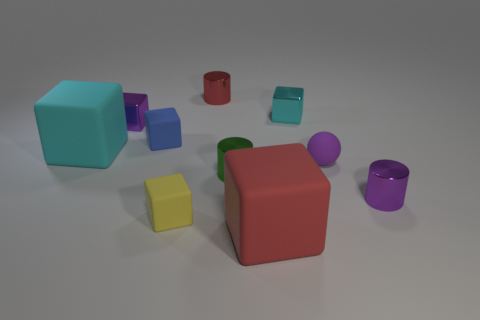There is a tiny matte sphere; is its color the same as the large cube behind the purple metallic cylinder?
Your answer should be very brief. No. What size is the purple object that is made of the same material as the big cyan object?
Your answer should be compact. Small. Are there any tiny rubber things of the same color as the rubber ball?
Your response must be concise. No. How many objects are either tiny purple things that are on the right side of the tiny red metal object or yellow things?
Your answer should be very brief. 3. Is the red cylinder made of the same material as the cyan block that is left of the tiny blue matte block?
Your response must be concise. No. What is the size of the cylinder that is the same color as the small ball?
Provide a short and direct response. Small. Are there any green objects made of the same material as the small blue block?
Provide a succinct answer. No. What number of objects are either yellow rubber cubes that are behind the big red block or shiny things that are behind the tiny blue matte object?
Make the answer very short. 4. There is a yellow thing; does it have the same shape as the big object that is behind the red block?
Offer a very short reply. Yes. What number of other objects are there of the same shape as the big cyan matte thing?
Your answer should be very brief. 5. 